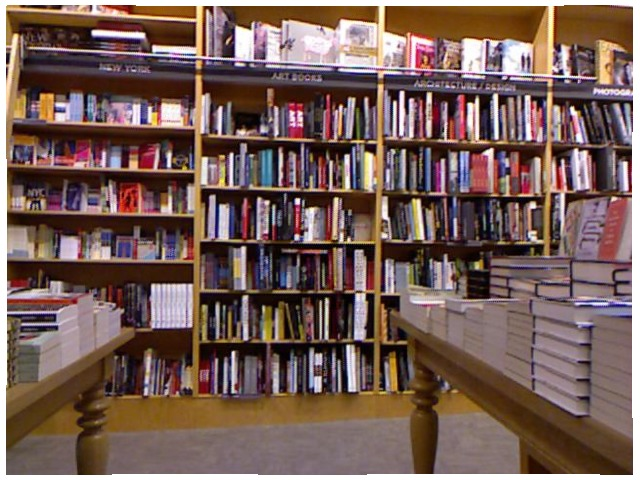<image>
Can you confirm if the book is under the table? No. The book is not positioned under the table. The vertical relationship between these objects is different. Is the book behind the book? No. The book is not behind the book. From this viewpoint, the book appears to be positioned elsewhere in the scene. 